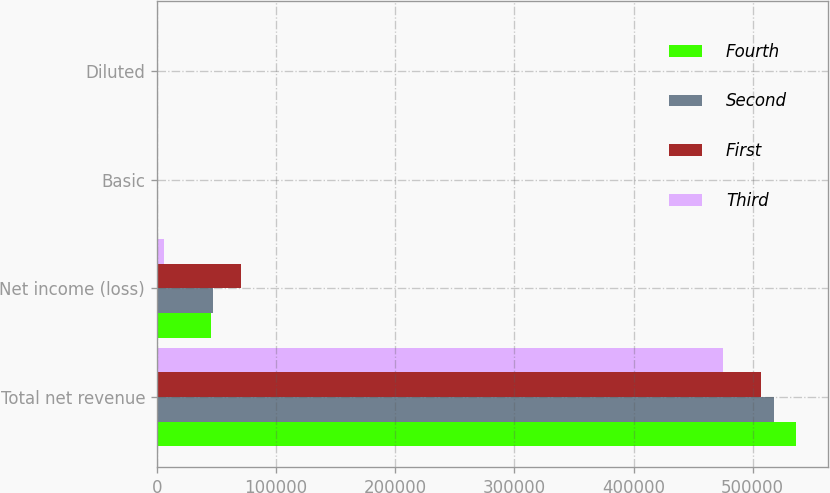<chart> <loc_0><loc_0><loc_500><loc_500><stacked_bar_chart><ecel><fcel>Total net revenue<fcel>Net income (loss)<fcel>Basic<fcel>Diluted<nl><fcel>Fourth<fcel>536695<fcel>45233<fcel>0.2<fcel>0.16<nl><fcel>Second<fcel>517619<fcel>47118<fcel>0.18<fcel>0.16<nl><fcel>First<fcel>507275<fcel>70696<fcel>0.25<fcel>0.24<nl><fcel>Third<fcel>475010<fcel>6346<fcel>0.02<fcel>0.02<nl></chart> 